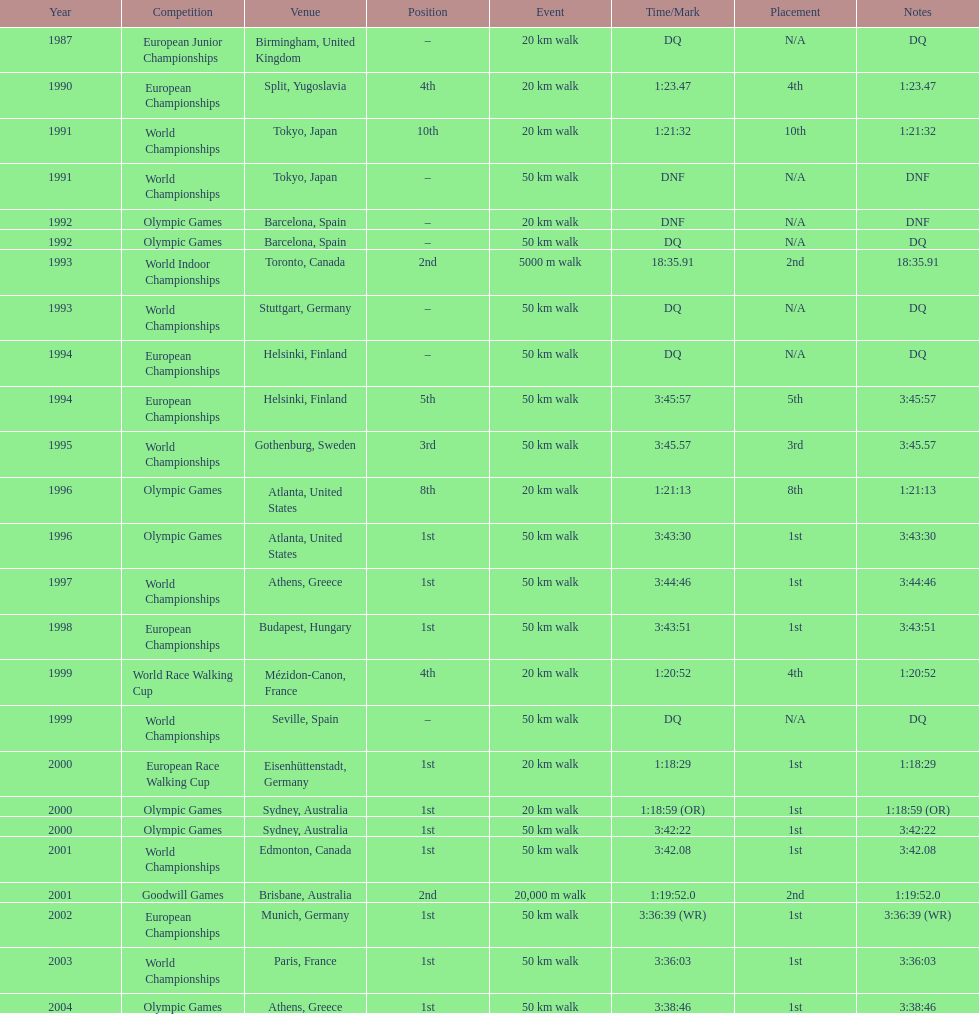How many events were at least 50 km? 17. 